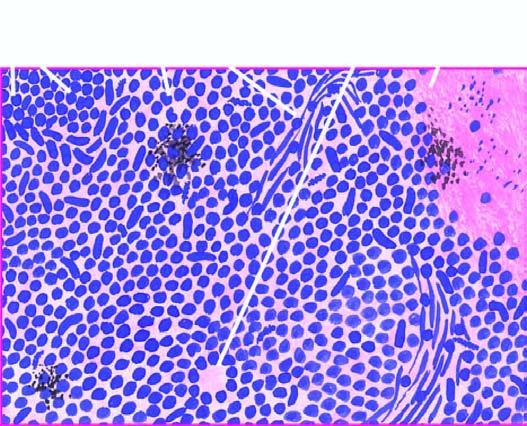re the tumour cells arranged in sheets, cords or aggregates and at places form pseudorosettes?
Answer the question using a single word or phrase. Yes 